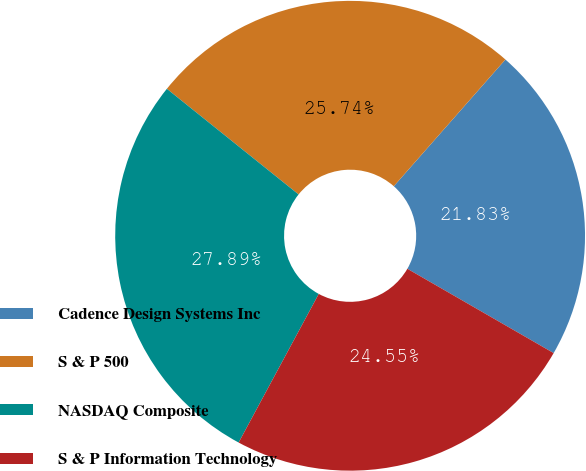<chart> <loc_0><loc_0><loc_500><loc_500><pie_chart><fcel>Cadence Design Systems Inc<fcel>S & P 500<fcel>NASDAQ Composite<fcel>S & P Information Technology<nl><fcel>21.83%<fcel>25.74%<fcel>27.89%<fcel>24.55%<nl></chart> 